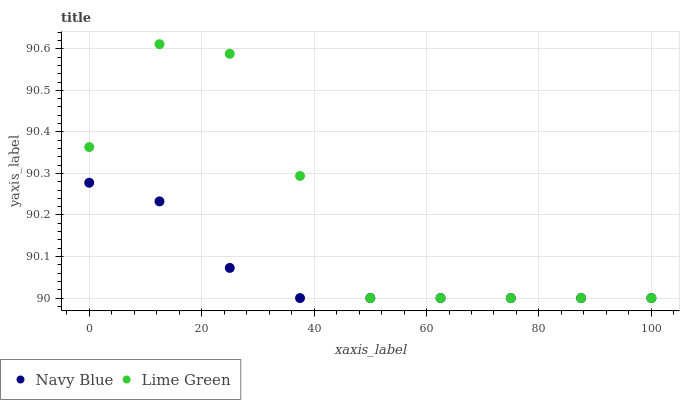Does Navy Blue have the minimum area under the curve?
Answer yes or no. Yes. Does Lime Green have the maximum area under the curve?
Answer yes or no. Yes. Does Lime Green have the minimum area under the curve?
Answer yes or no. No. Is Navy Blue the smoothest?
Answer yes or no. Yes. Is Lime Green the roughest?
Answer yes or no. Yes. Is Lime Green the smoothest?
Answer yes or no. No. Does Navy Blue have the lowest value?
Answer yes or no. Yes. Does Lime Green have the highest value?
Answer yes or no. Yes. Does Lime Green intersect Navy Blue?
Answer yes or no. Yes. Is Lime Green less than Navy Blue?
Answer yes or no. No. Is Lime Green greater than Navy Blue?
Answer yes or no. No. 